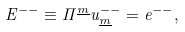<formula> <loc_0><loc_0><loc_500><loc_500>E ^ { - - } \equiv \Pi ^ { \underline { m } } u _ { \underline { m } } ^ { - - } = e ^ { - - } ,</formula> 